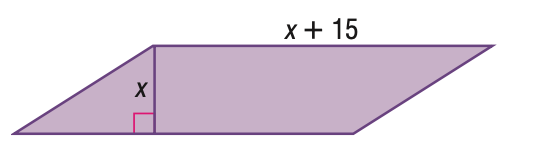Question: Find the height of the parallelogram given its area with 100 square units.
Choices:
A. 5
B. 10
C. 15
D. 20
Answer with the letter. Answer: A Question: Find the base of the parallelogram given its area with 100 square units.
Choices:
A. 15
B. 20
C. 25
D. 30
Answer with the letter. Answer: B 